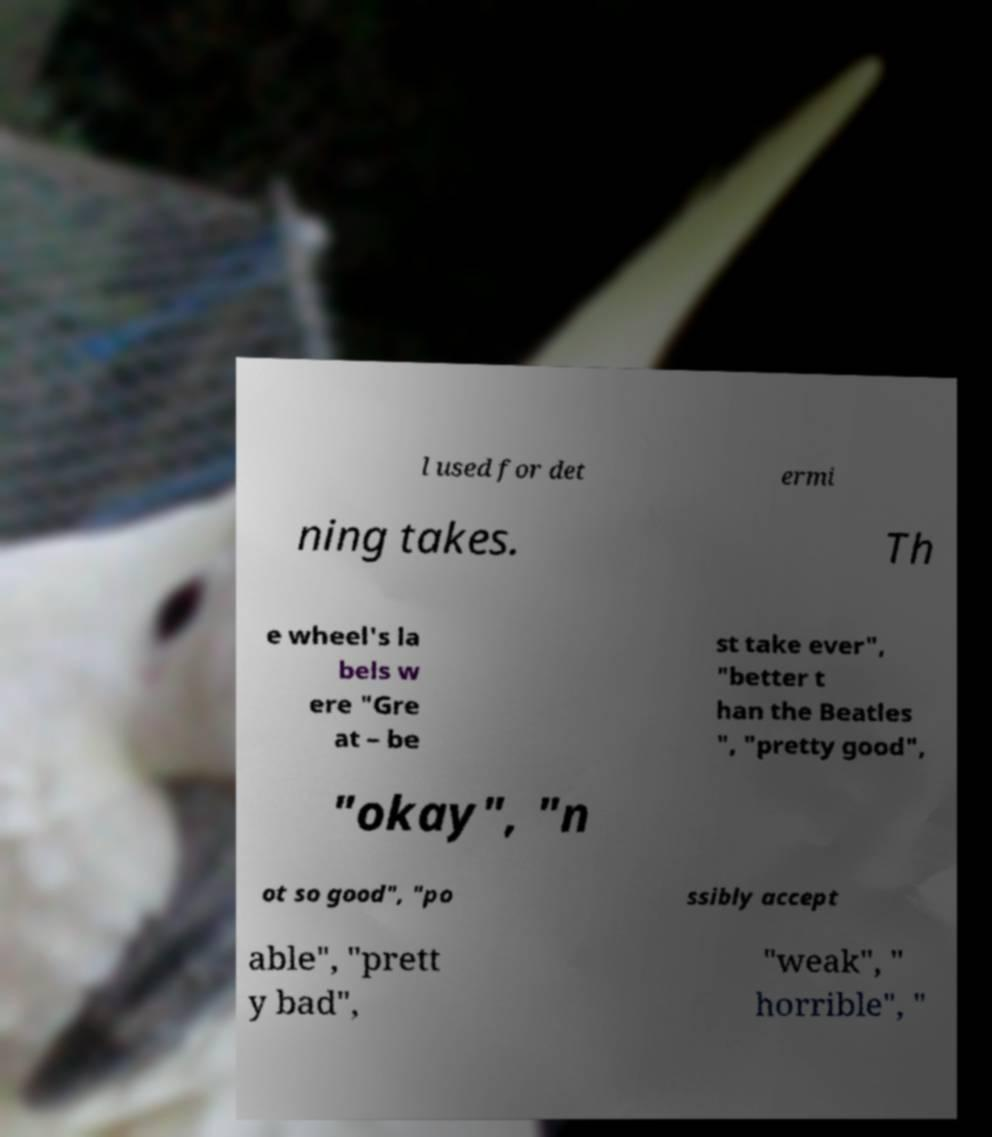Could you assist in decoding the text presented in this image and type it out clearly? l used for det ermi ning takes. Th e wheel's la bels w ere "Gre at – be st take ever", "better t han the Beatles ", "pretty good", "okay", "n ot so good", "po ssibly accept able", "prett y bad", "weak", " horrible", " 